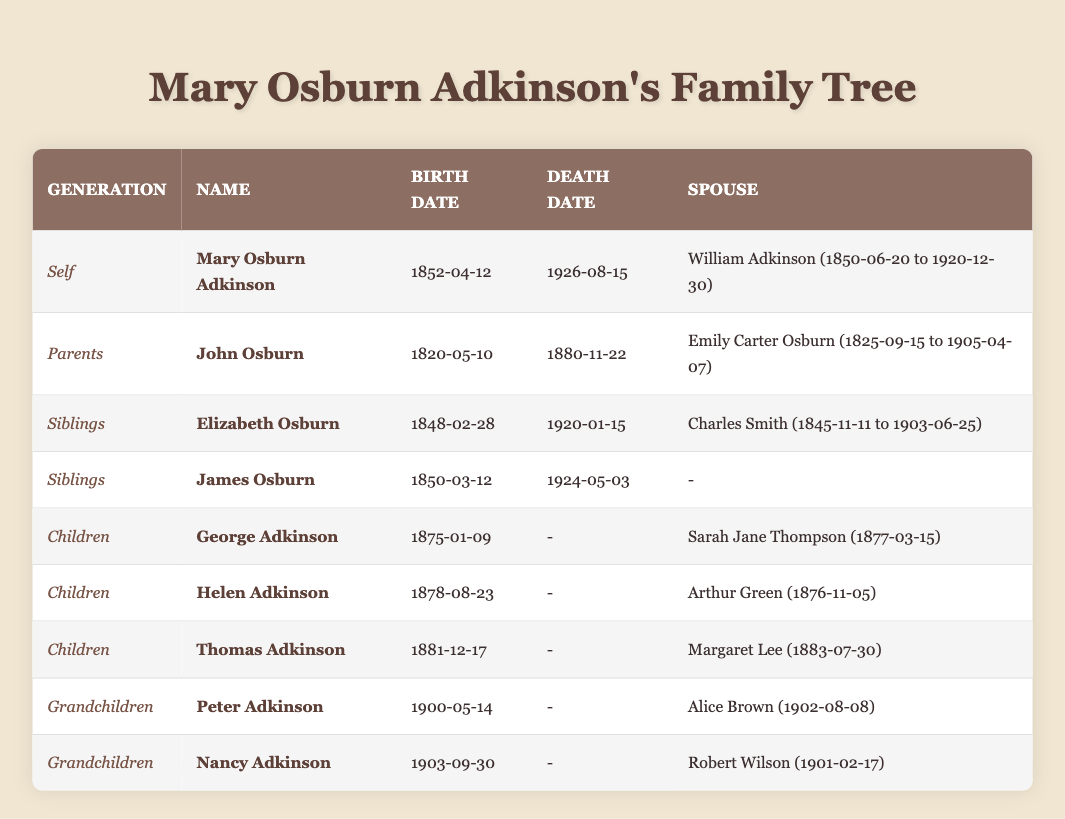What is the birth date of Mary Osburn Adkinson? The birth date of Mary Osburn Adkinson is provided in the "Birth Date" column for her entry in the table. It states "1852-04-12".
Answer: 1852-04-12 Who are the parents of Mary Osburn Adkinson? The parents are listed in the "Parents" section of the table. Their names are "John Osburn" and "Emily Carter Osburn".
Answer: John Osburn and Emily Carter Osburn What is the death date of Elizabeth Osburn? The death date is listed in the table under Elizabeth Osburn's entry in the "Death Date" column, which shows "1920-01-15".
Answer: 1920-01-15 How many children did Mary Osburn Adkinson have? By counting the entries under the "Children" section in the table, I find there are three named: George, Helen, and Thomas.
Answer: 3 Is James Osburn listed as married in the table? The table entry for James Osburn indicates there is no spouse listed ("-"), so he is not recorded as married.
Answer: No Who was the spouse of George Adkinson? The spouse of George Adkinson can be found in his entry under the "Spouse" column, which states "Sarah Jane Thompson".
Answer: Sarah Jane Thompson What is the birth date of the youngest grandchild, Nancy Adkinson? The birth date of Nancy Adkinson is recorded in the "Birth Date" column of her entry, which shows "1903-09-30".
Answer: 1903-09-30 Which sibling of Mary Osburn Adkinson was born first? Comparing the birth dates of Elizabeth Osburn (1848-02-28) and James Osburn (1850-03-12), Elizabeth was born earlier than James.
Answer: Elizabeth Osburn How many people in Mary Osburn Adkinson's family tree have exactly two known spouses? Reviewing the table entries, only Elizabeth Osburn has a known spouse listed. Mary has one spouse, and the others do not have two. Thus, Elizabeth is the only one.
Answer: 1 What is the birth year of Thomas Adkinson? The birth date of Thomas Adkinson is "1881-12-17", so his birth year is obtained from this date, which is 1881.
Answer: 1881 What is the average birth year of Mary Osburn Adkinson's children? The birth years of her children are 1875 (George), 1878 (Helen), and 1881 (Thomas). The average birth year is calculated as (1875 + 1878 + 1881)/3 = 1878.
Answer: 1878 Which grandchild was born sooner, Peter Adkinson or Nancy Adkinson? Comparing their birth dates, Peter was born on "1900-05-14" and Nancy was born on "1903-09-30". Since 1900 is earlier than 1903, Peter was born sooner.
Answer: Peter Adkinson What are the death dates of both of Mary Osburn Adkinson's parents? The table provides that John Osburn died on "1880-11-22" and Emily Carter Osburn died on "1905-04-07". Combining these results gives both death dates.
Answer: John Osburn: 1880-11-22, Emily Carter Osburn: 1905-04-07 